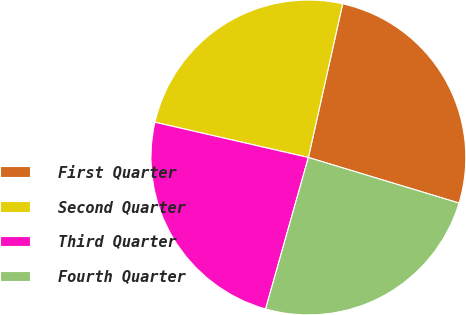Convert chart. <chart><loc_0><loc_0><loc_500><loc_500><pie_chart><fcel>First Quarter<fcel>Second Quarter<fcel>Third Quarter<fcel>Fourth Quarter<nl><fcel>26.18%<fcel>24.9%<fcel>24.21%<fcel>24.7%<nl></chart> 